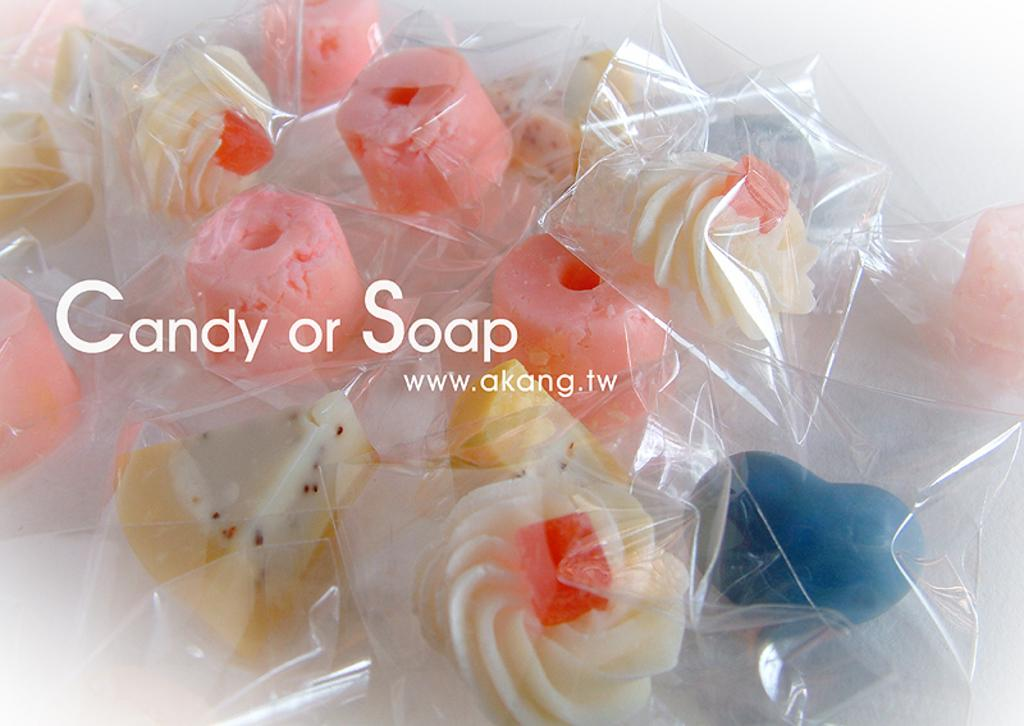What type of items are in the packets in the image? There are candies in packets in the image. What else can be seen in the image besides the candies? There is some text in the image. What color is the background of the image? The background of the image is white. What type of yarn is being used to create the stocking in the image? There is no yarn or stocking present in the image; it features candies in packets and some text. 